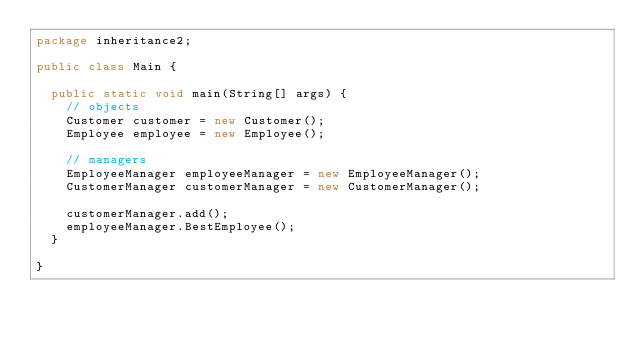<code> <loc_0><loc_0><loc_500><loc_500><_Java_>package inheritance2;

public class Main {

	public static void main(String[] args) {
		// objects
		Customer customer = new Customer();
		Employee employee = new Employee();

		// managers
		EmployeeManager employeeManager = new EmployeeManager();
		CustomerManager customerManager = new CustomerManager();

		customerManager.add();
		employeeManager.BestEmployee();
	}

}
</code> 